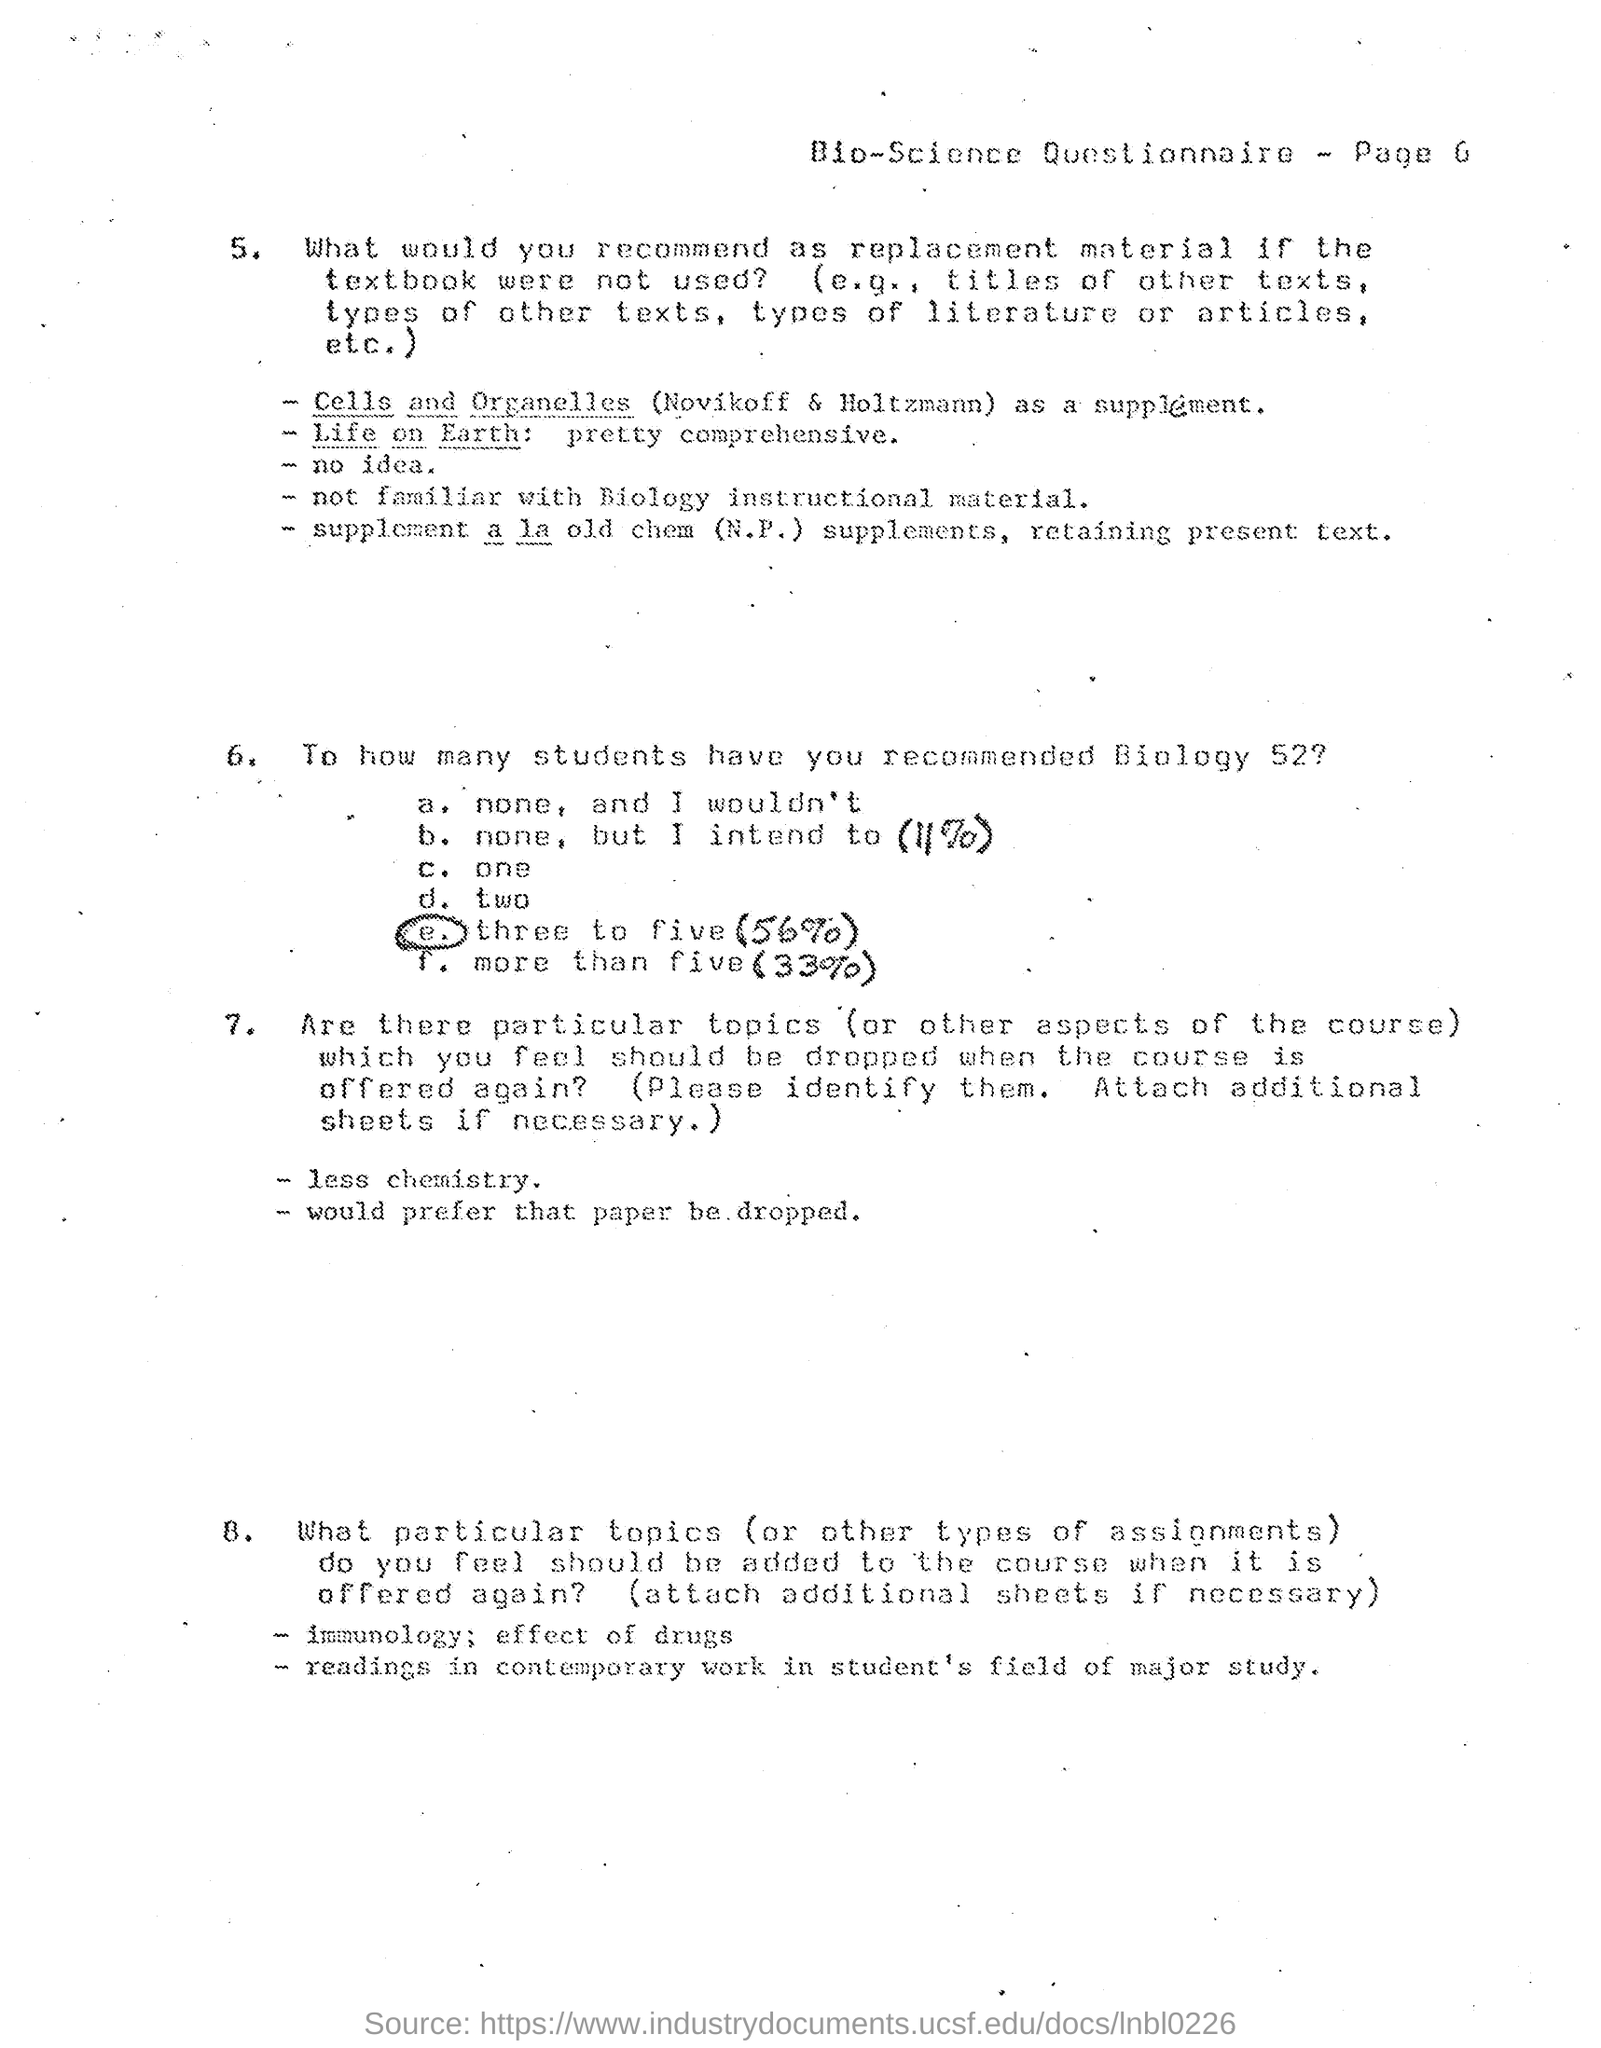List a handful of essential elements in this visual. I am a biology student taking a questionnaire. The document shows page 6 of the "Bio-Science Questionnaire. This is a declaration that this document is a Bio-Science Questionnaire. 